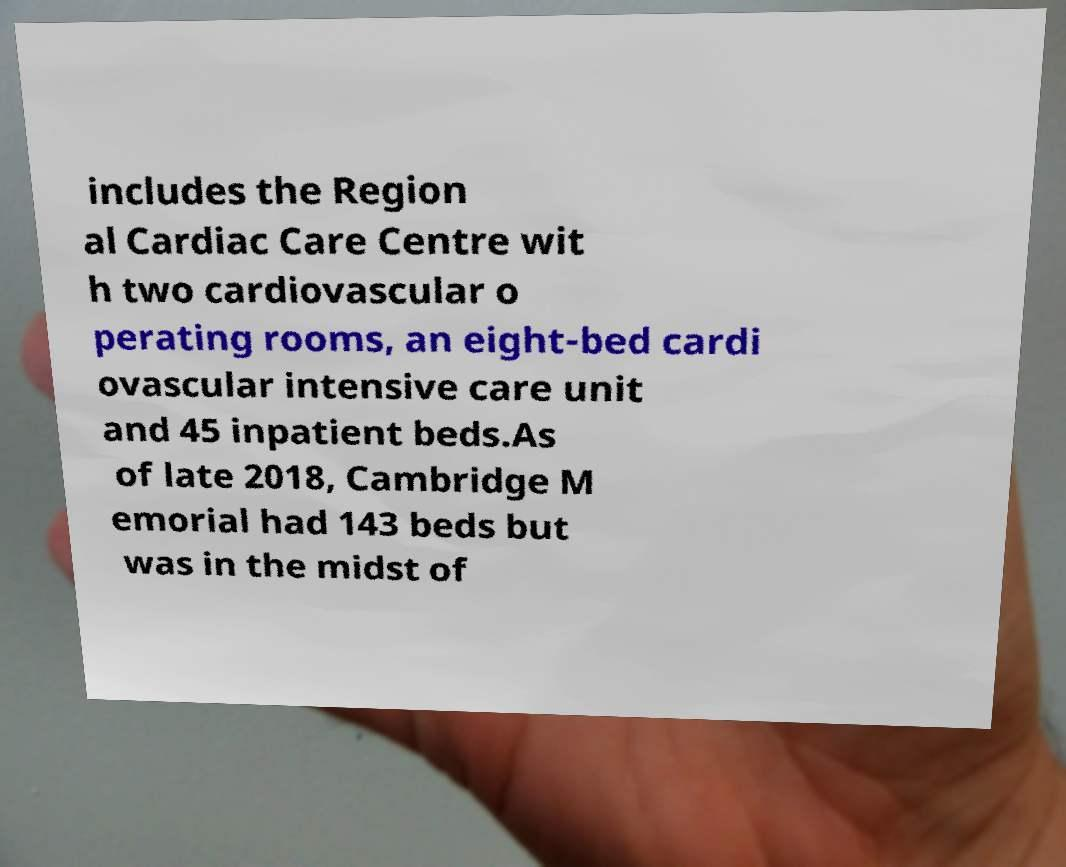For documentation purposes, I need the text within this image transcribed. Could you provide that? includes the Region al Cardiac Care Centre wit h two cardiovascular o perating rooms, an eight-bed cardi ovascular intensive care unit and 45 inpatient beds.As of late 2018, Cambridge M emorial had 143 beds but was in the midst of 